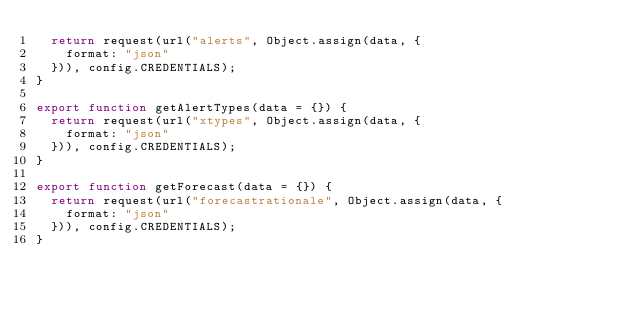Convert code to text. <code><loc_0><loc_0><loc_500><loc_500><_JavaScript_>  return request(url("alerts", Object.assign(data, {
    format: "json"
  })), config.CREDENTIALS);
}

export function getAlertTypes(data = {}) {
  return request(url("xtypes", Object.assign(data, {
    format: "json"
  })), config.CREDENTIALS);
}

export function getForecast(data = {}) {
  return request(url("forecastrationale", Object.assign(data, {
    format: "json"
  })), config.CREDENTIALS);
}
</code> 